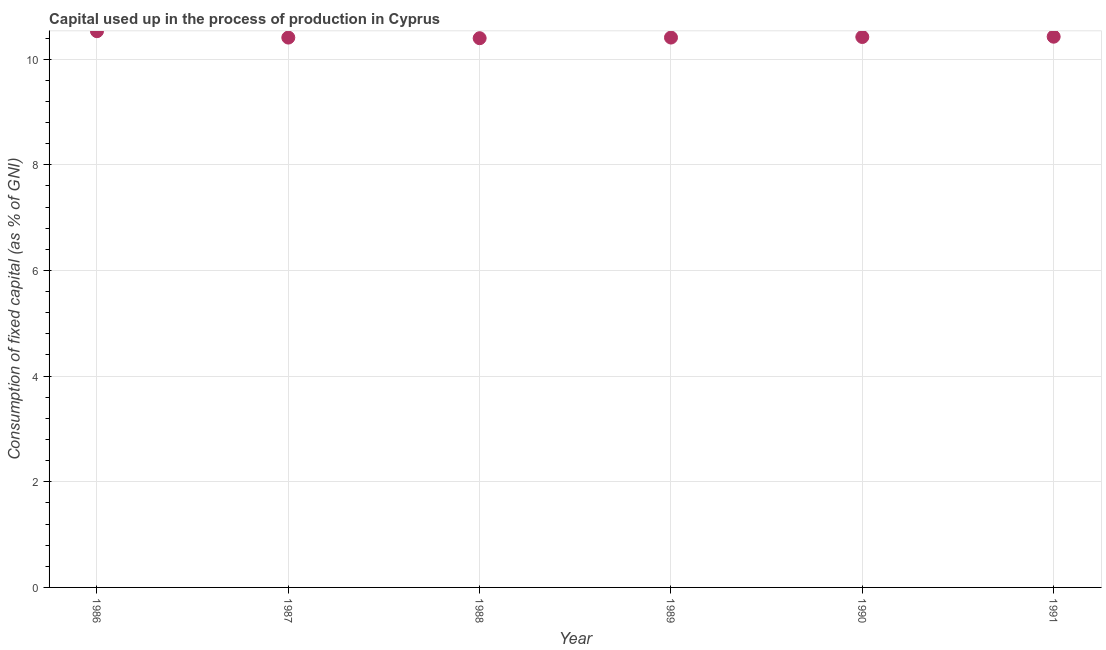What is the consumption of fixed capital in 1986?
Your response must be concise. 10.53. Across all years, what is the maximum consumption of fixed capital?
Give a very brief answer. 10.53. Across all years, what is the minimum consumption of fixed capital?
Offer a terse response. 10.4. In which year was the consumption of fixed capital maximum?
Offer a very short reply. 1986. What is the sum of the consumption of fixed capital?
Your answer should be compact. 62.59. What is the difference between the consumption of fixed capital in 1986 and 1988?
Offer a terse response. 0.13. What is the average consumption of fixed capital per year?
Your response must be concise. 10.43. What is the median consumption of fixed capital?
Your response must be concise. 10.41. What is the ratio of the consumption of fixed capital in 1986 to that in 1989?
Provide a short and direct response. 1.01. Is the consumption of fixed capital in 1988 less than that in 1989?
Your response must be concise. Yes. What is the difference between the highest and the second highest consumption of fixed capital?
Offer a terse response. 0.1. What is the difference between the highest and the lowest consumption of fixed capital?
Your answer should be very brief. 0.13. In how many years, is the consumption of fixed capital greater than the average consumption of fixed capital taken over all years?
Provide a succinct answer. 1. How many years are there in the graph?
Offer a very short reply. 6. What is the difference between two consecutive major ticks on the Y-axis?
Your answer should be compact. 2. Are the values on the major ticks of Y-axis written in scientific E-notation?
Provide a short and direct response. No. Does the graph contain any zero values?
Provide a succinct answer. No. Does the graph contain grids?
Provide a short and direct response. Yes. What is the title of the graph?
Provide a short and direct response. Capital used up in the process of production in Cyprus. What is the label or title of the X-axis?
Offer a terse response. Year. What is the label or title of the Y-axis?
Your answer should be very brief. Consumption of fixed capital (as % of GNI). What is the Consumption of fixed capital (as % of GNI) in 1986?
Your answer should be very brief. 10.53. What is the Consumption of fixed capital (as % of GNI) in 1987?
Your answer should be compact. 10.41. What is the Consumption of fixed capital (as % of GNI) in 1988?
Ensure brevity in your answer.  10.4. What is the Consumption of fixed capital (as % of GNI) in 1989?
Provide a succinct answer. 10.41. What is the Consumption of fixed capital (as % of GNI) in 1990?
Offer a very short reply. 10.42. What is the Consumption of fixed capital (as % of GNI) in 1991?
Provide a short and direct response. 10.42. What is the difference between the Consumption of fixed capital (as % of GNI) in 1986 and 1987?
Your response must be concise. 0.12. What is the difference between the Consumption of fixed capital (as % of GNI) in 1986 and 1988?
Your answer should be compact. 0.13. What is the difference between the Consumption of fixed capital (as % of GNI) in 1986 and 1989?
Keep it short and to the point. 0.12. What is the difference between the Consumption of fixed capital (as % of GNI) in 1986 and 1990?
Provide a short and direct response. 0.11. What is the difference between the Consumption of fixed capital (as % of GNI) in 1986 and 1991?
Provide a succinct answer. 0.1. What is the difference between the Consumption of fixed capital (as % of GNI) in 1987 and 1988?
Keep it short and to the point. 0.01. What is the difference between the Consumption of fixed capital (as % of GNI) in 1987 and 1989?
Ensure brevity in your answer.  -0. What is the difference between the Consumption of fixed capital (as % of GNI) in 1987 and 1990?
Your answer should be compact. -0.01. What is the difference between the Consumption of fixed capital (as % of GNI) in 1987 and 1991?
Your answer should be compact. -0.02. What is the difference between the Consumption of fixed capital (as % of GNI) in 1988 and 1989?
Your answer should be compact. -0.01. What is the difference between the Consumption of fixed capital (as % of GNI) in 1988 and 1990?
Make the answer very short. -0.02. What is the difference between the Consumption of fixed capital (as % of GNI) in 1988 and 1991?
Make the answer very short. -0.03. What is the difference between the Consumption of fixed capital (as % of GNI) in 1989 and 1990?
Offer a very short reply. -0.01. What is the difference between the Consumption of fixed capital (as % of GNI) in 1989 and 1991?
Your answer should be compact. -0.02. What is the difference between the Consumption of fixed capital (as % of GNI) in 1990 and 1991?
Your answer should be very brief. -0.01. What is the ratio of the Consumption of fixed capital (as % of GNI) in 1986 to that in 1988?
Give a very brief answer. 1.01. What is the ratio of the Consumption of fixed capital (as % of GNI) in 1986 to that in 1990?
Offer a very short reply. 1.01. What is the ratio of the Consumption of fixed capital (as % of GNI) in 1987 to that in 1988?
Provide a succinct answer. 1. What is the ratio of the Consumption of fixed capital (as % of GNI) in 1987 to that in 1990?
Offer a very short reply. 1. What is the ratio of the Consumption of fixed capital (as % of GNI) in 1988 to that in 1990?
Ensure brevity in your answer.  1. What is the ratio of the Consumption of fixed capital (as % of GNI) in 1989 to that in 1990?
Provide a short and direct response. 1. What is the ratio of the Consumption of fixed capital (as % of GNI) in 1989 to that in 1991?
Offer a very short reply. 1. What is the ratio of the Consumption of fixed capital (as % of GNI) in 1990 to that in 1991?
Ensure brevity in your answer.  1. 